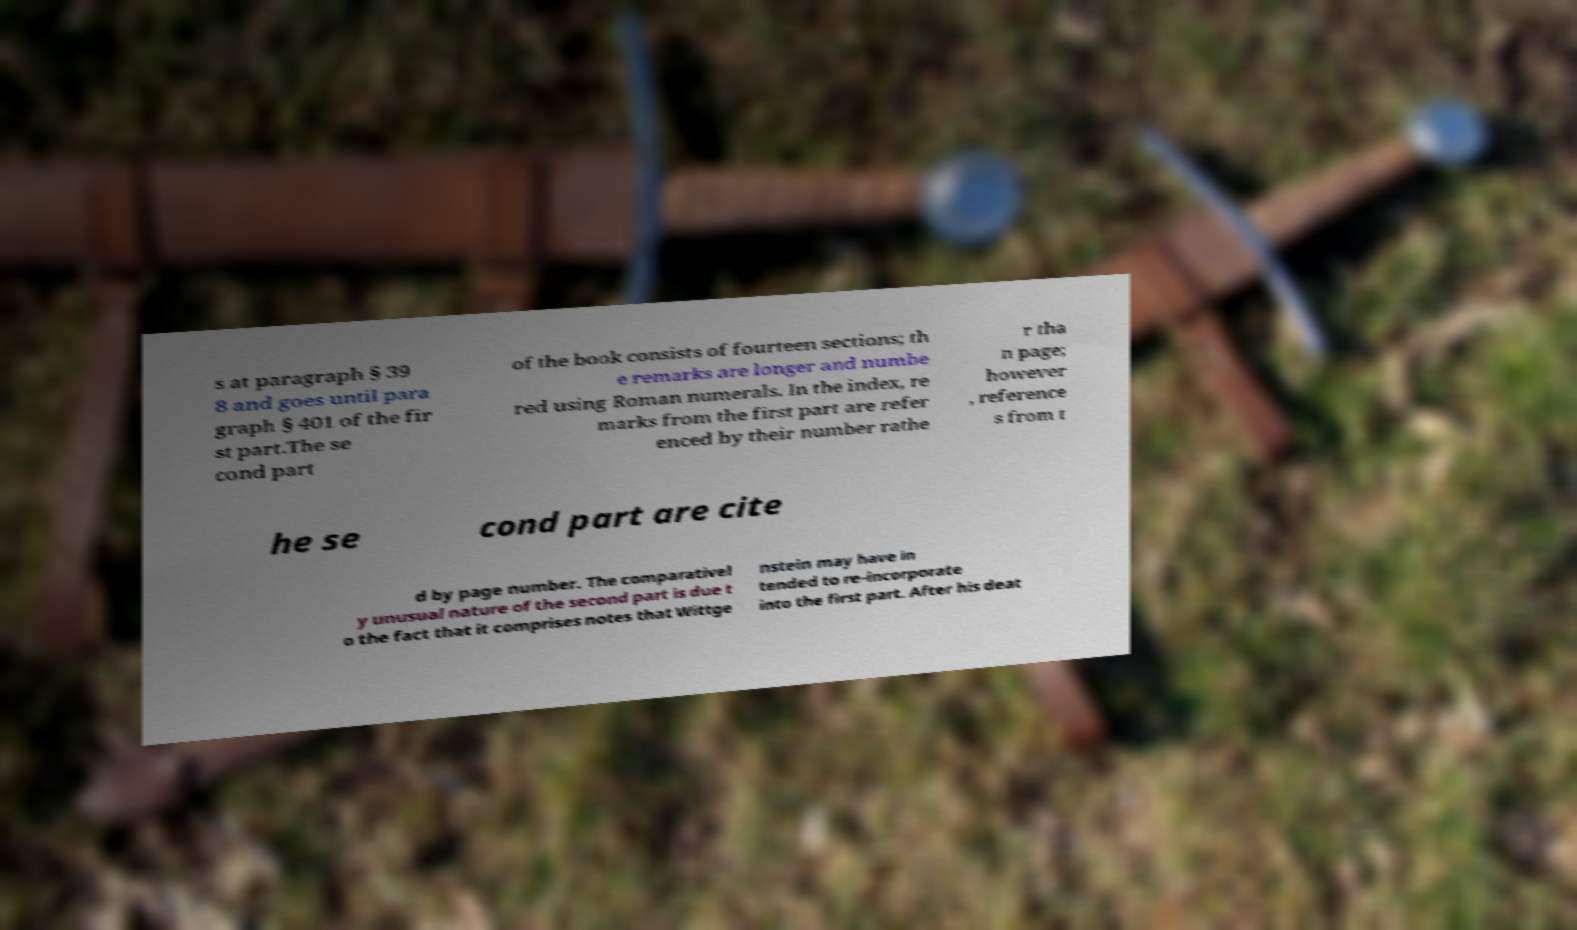What messages or text are displayed in this image? I need them in a readable, typed format. s at paragraph § 39 8 and goes until para graph § 401 of the fir st part.The se cond part of the book consists of fourteen sections; th e remarks are longer and numbe red using Roman numerals. In the index, re marks from the first part are refer enced by their number rathe r tha n page; however , reference s from t he se cond part are cite d by page number. The comparativel y unusual nature of the second part is due t o the fact that it comprises notes that Wittge nstein may have in tended to re-incorporate into the first part. After his deat 